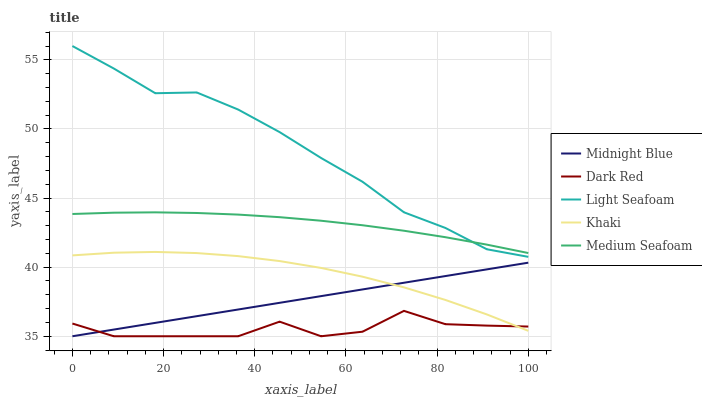Does Dark Red have the minimum area under the curve?
Answer yes or no. Yes. Does Light Seafoam have the maximum area under the curve?
Answer yes or no. Yes. Does Khaki have the minimum area under the curve?
Answer yes or no. No. Does Khaki have the maximum area under the curve?
Answer yes or no. No. Is Midnight Blue the smoothest?
Answer yes or no. Yes. Is Dark Red the roughest?
Answer yes or no. Yes. Is Light Seafoam the smoothest?
Answer yes or no. No. Is Light Seafoam the roughest?
Answer yes or no. No. Does Dark Red have the lowest value?
Answer yes or no. Yes. Does Light Seafoam have the lowest value?
Answer yes or no. No. Does Light Seafoam have the highest value?
Answer yes or no. Yes. Does Khaki have the highest value?
Answer yes or no. No. Is Khaki less than Light Seafoam?
Answer yes or no. Yes. Is Light Seafoam greater than Dark Red?
Answer yes or no. Yes. Does Light Seafoam intersect Medium Seafoam?
Answer yes or no. Yes. Is Light Seafoam less than Medium Seafoam?
Answer yes or no. No. Is Light Seafoam greater than Medium Seafoam?
Answer yes or no. No. Does Khaki intersect Light Seafoam?
Answer yes or no. No. 